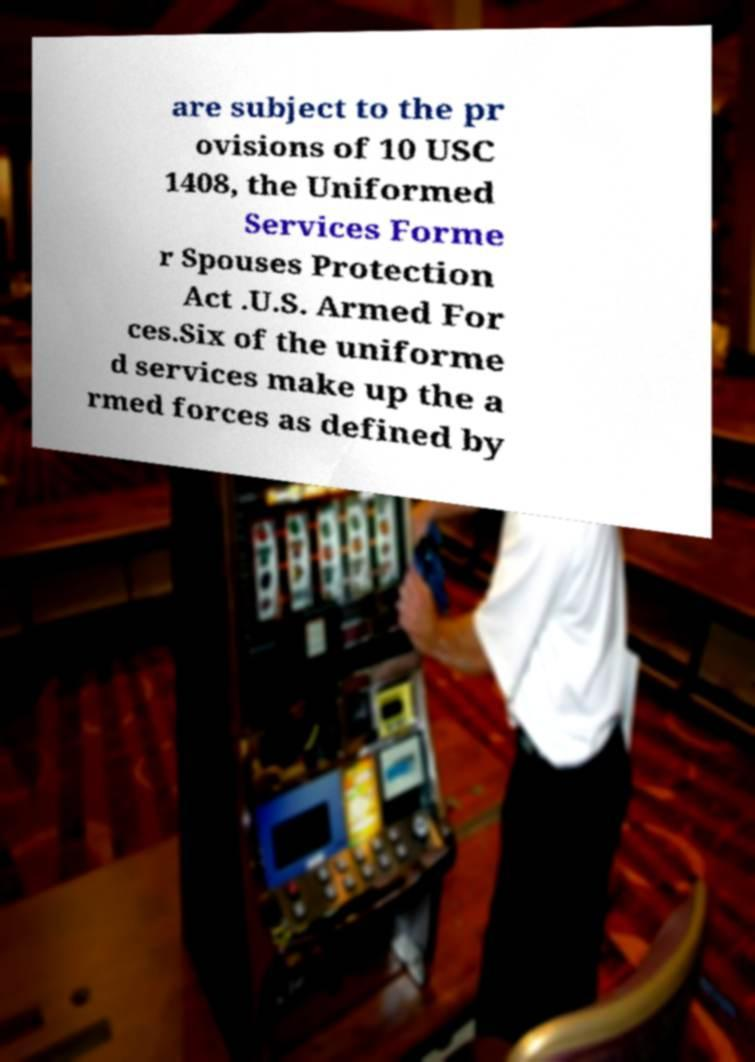Please identify and transcribe the text found in this image. are subject to the pr ovisions of 10 USC 1408, the Uniformed Services Forme r Spouses Protection Act .U.S. Armed For ces.Six of the uniforme d services make up the a rmed forces as defined by 